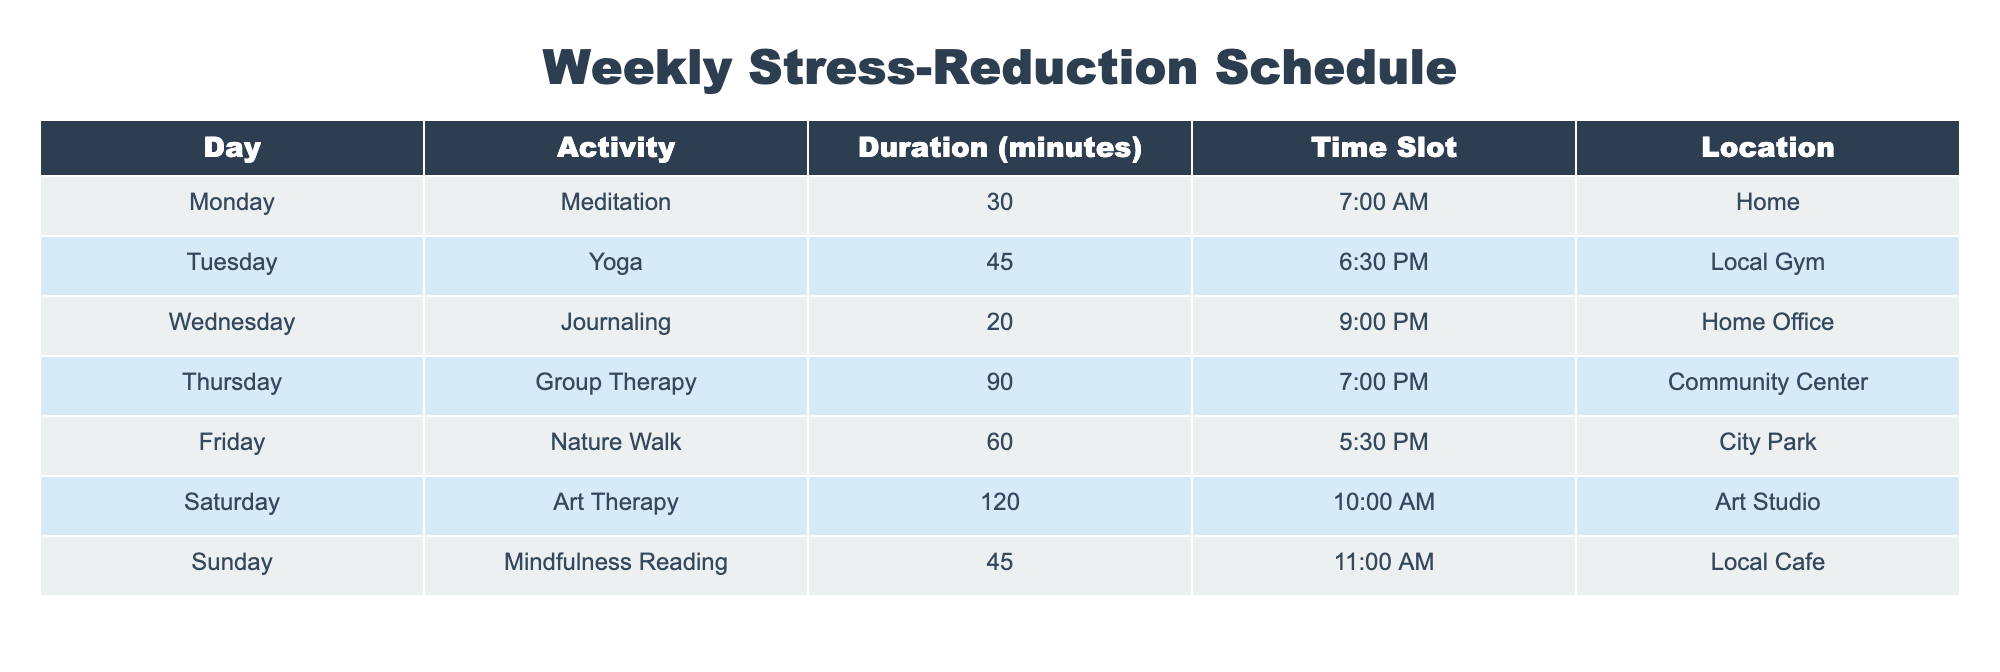What activity is scheduled for Saturday? The table lists the activities for each day of the week. Looking at Saturday, the activity listed is "Art Therapy".
Answer: Art Therapy How long is the Group Therapy session on Thursday? The table specifies the duration for each activity. For Thursday, the duration listed for Group Therapy is 90 minutes.
Answer: 90 minutes Which activity has the longest duration? By comparing the durations of all activities listed in the table, Art Therapy on Saturday lasts the longest at 120 minutes.
Answer: Art Therapy What is the total time allotted for stress-reduction activities from Monday to Friday? To find the total time, sum the durations of each activity from Monday (30 minutes), Tuesday (45 minutes), Wednesday (20 minutes), Thursday (90 minutes), and Friday (60 minutes). The total is calculated as 30 + 45 + 20 + 90 + 60 = 245 minutes.
Answer: 245 minutes Is there an activity scheduled at 7:00 PM? Checking the table for any activity scheduled at 7:00 PM, we see that Group Therapy is scheduled at this time on Thursday.
Answer: Yes On which day is the Nature Walk scheduled? The table provides a clear mapping of activities to days. Nature Walk is scheduled for Friday.
Answer: Friday What is the average duration of the activities for the weekend (Saturday and Sunday)? The durations for Saturday and Sunday are 120 minutes (Art Therapy) and 45 minutes (Mindfulness Reading), respectively. To find the average, sum the durations (120 + 45 = 165) and divide by the number of days (2), resulting in an average of 82.5 minutes.
Answer: 82.5 minutes Which activity occurs on a weekday and lasts 60 minutes or more? Reviewing the table, both Group Therapy (90 minutes) on Thursday and Nature Walk (60 minutes) on Friday are activities that meet this criterion, which makes Friday and Thursday valid answers.
Answer: Group Therapy and Nature Walk What is the total number of different locations listed for activities? The table mentions four unique locations: Home, Local Gym, Community Center, City Park, Art Studio, and Local Cafe, which counts to six different locations.
Answer: 6 locations 